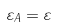Convert formula to latex. <formula><loc_0><loc_0><loc_500><loc_500>\varepsilon _ { A } = \varepsilon</formula> 